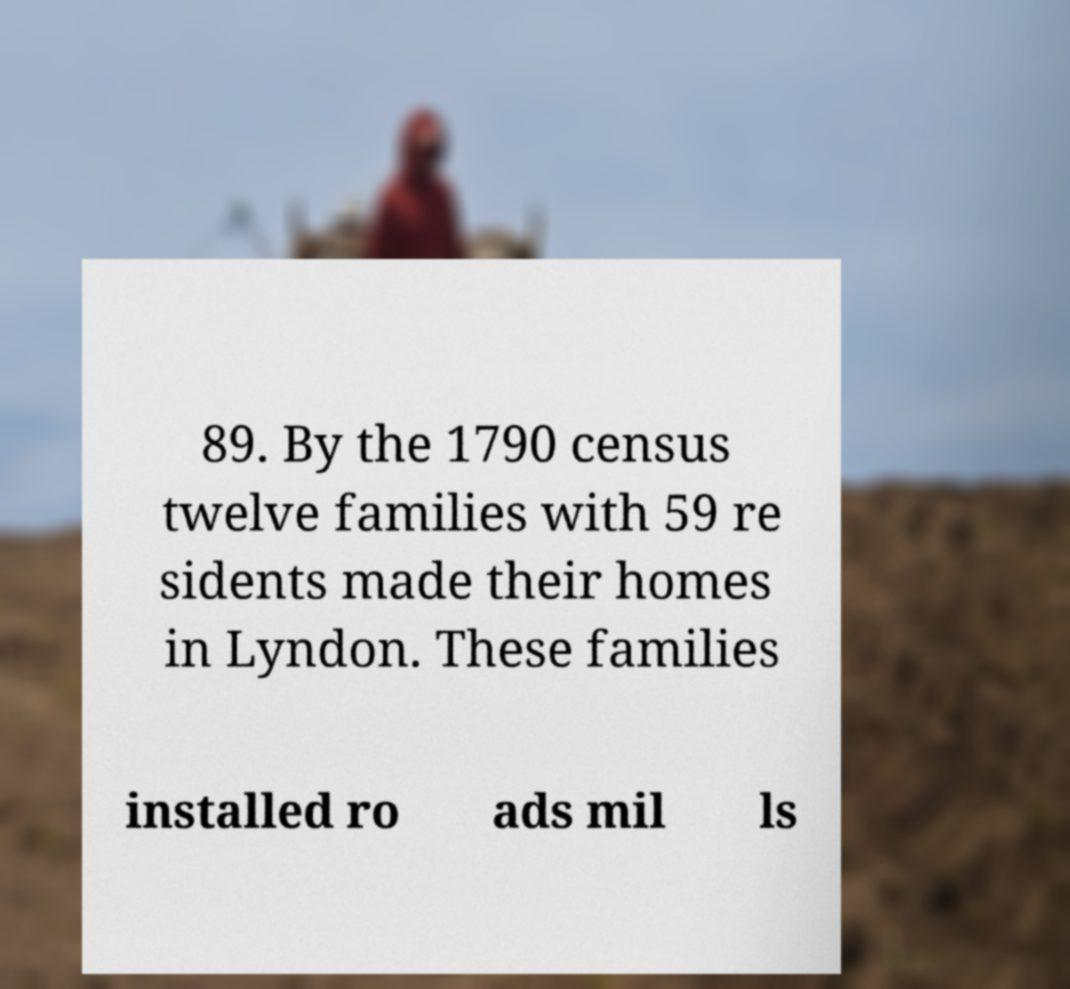For documentation purposes, I need the text within this image transcribed. Could you provide that? 89. By the 1790 census twelve families with 59 re sidents made their homes in Lyndon. These families installed ro ads mil ls 